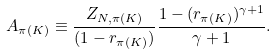<formula> <loc_0><loc_0><loc_500><loc_500>A _ { \pi ( K ) } \equiv \frac { Z _ { N , \pi ( K ) } } { ( 1 - r _ { \pi ( K ) } ) } \frac { 1 - ( r _ { \pi ( K ) } ) ^ { \gamma + 1 } } { \gamma + 1 } .</formula> 